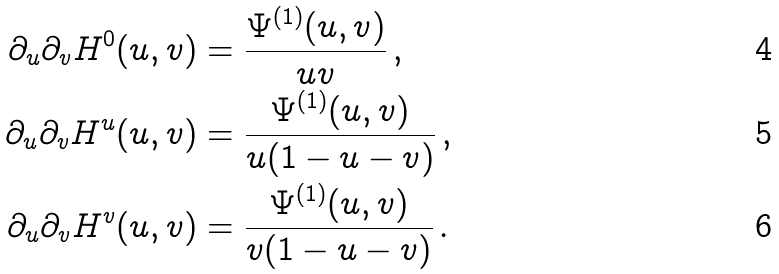<formula> <loc_0><loc_0><loc_500><loc_500>\partial _ { u } \partial _ { v } H ^ { 0 } ( u , v ) & = \frac { \Psi ^ { ( 1 ) } ( u , v ) } { u v } \, , \\ \partial _ { u } \partial _ { v } H ^ { u } ( u , v ) & = \frac { \Psi ^ { ( 1 ) } ( u , v ) } { u ( 1 - u - v ) } \, , \\ \partial _ { u } \partial _ { v } H ^ { v } ( u , v ) & = \frac { \Psi ^ { ( 1 ) } ( u , v ) } { v ( 1 - u - v ) } \, .</formula> 